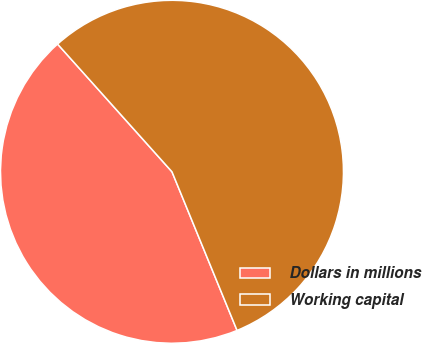Convert chart. <chart><loc_0><loc_0><loc_500><loc_500><pie_chart><fcel>Dollars in millions<fcel>Working capital<nl><fcel>44.57%<fcel>55.43%<nl></chart> 